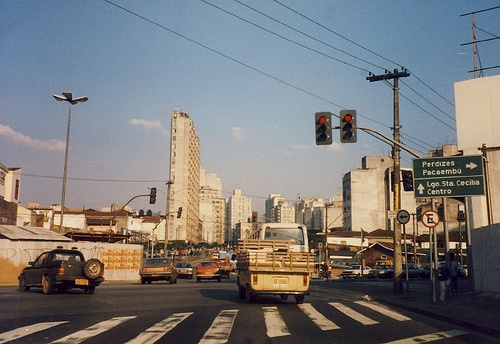Describe the objects in this image and their specific colors. I can see truck in gray, tan, black, maroon, and olive tones, truck in gray, black, and maroon tones, bus in gray and tan tones, traffic light in gray, darkgray, and black tones, and car in gray, maroon, and black tones in this image. 